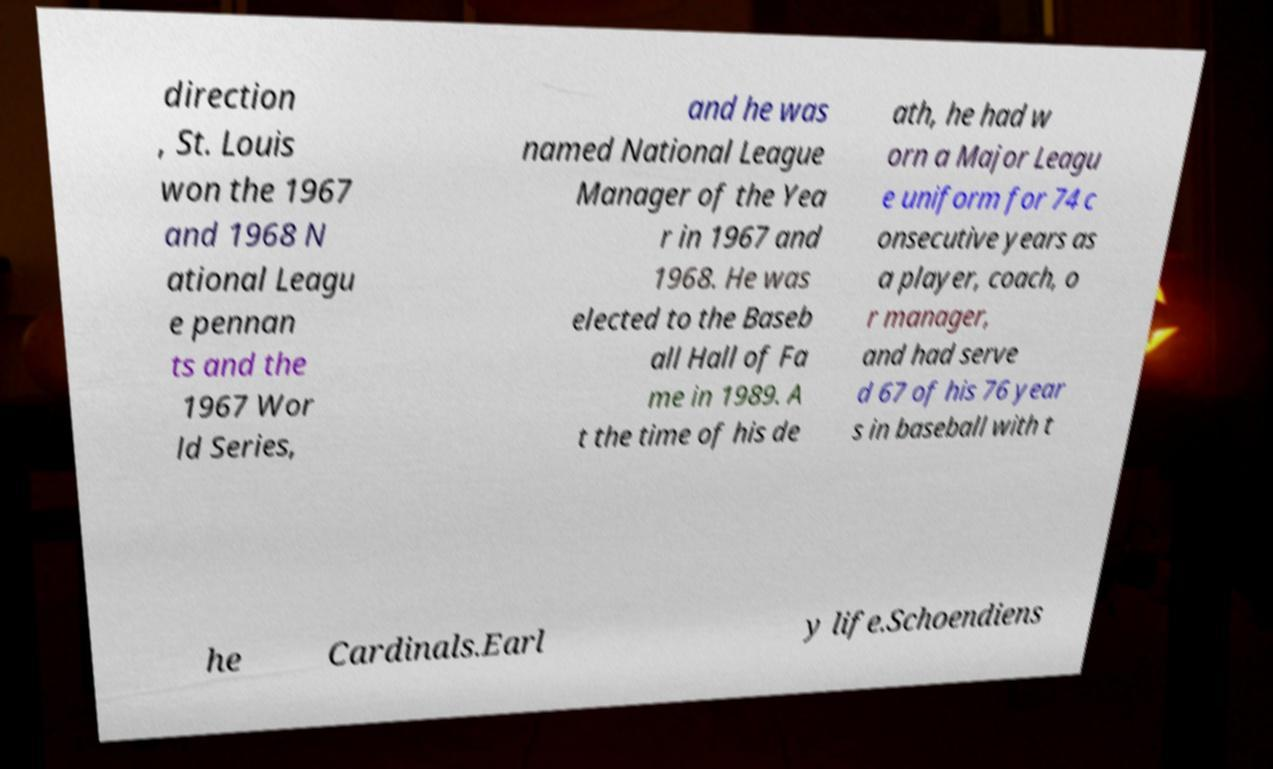Please identify and transcribe the text found in this image. direction , St. Louis won the 1967 and 1968 N ational Leagu e pennan ts and the 1967 Wor ld Series, and he was named National League Manager of the Yea r in 1967 and 1968. He was elected to the Baseb all Hall of Fa me in 1989. A t the time of his de ath, he had w orn a Major Leagu e uniform for 74 c onsecutive years as a player, coach, o r manager, and had serve d 67 of his 76 year s in baseball with t he Cardinals.Earl y life.Schoendiens 